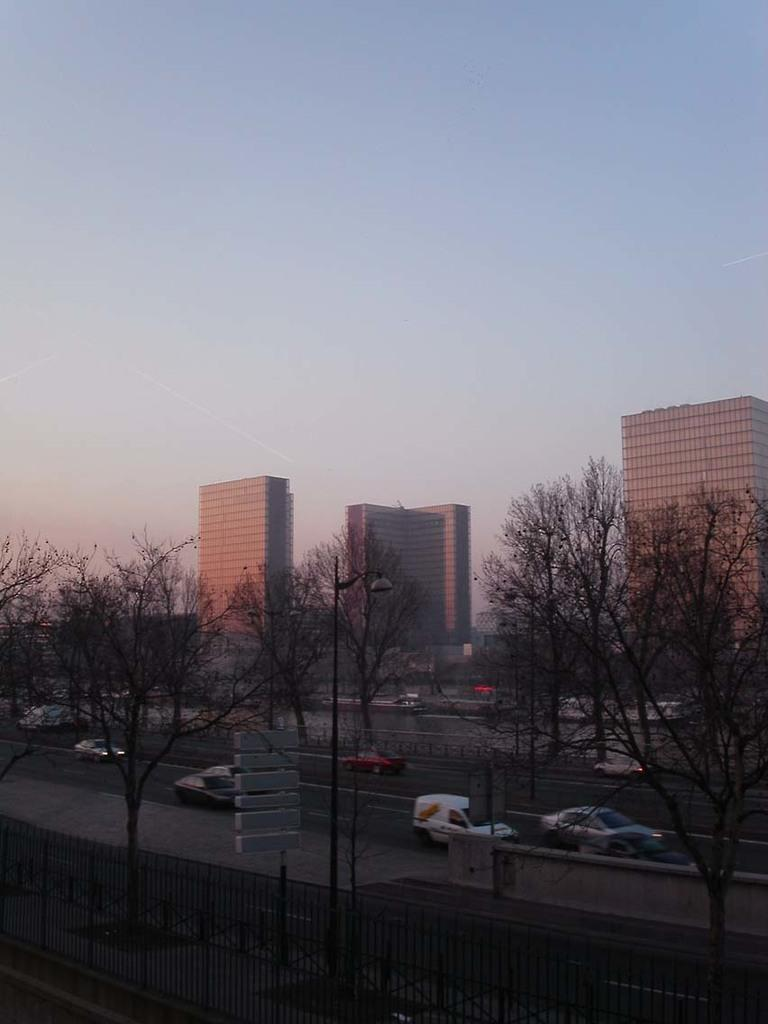What type of structures can be seen in the image? There are buildings in the image. What other natural elements are present in the image? There are trees in the image. What mode of transportation can be seen in the image? There are moving vehicles on the road in the image. What safety feature is visible in the image? There is railing in the image. What type of information might be conveyed by the sign boards in the image? The sign boards in the image might convey information about directions, warnings, or advertisements. What is visible in the background of the image? The sky is visible in the background of the image. What type of bell can be heard ringing in the image? There is no bell present in the image, and therefore no sound can be heard. What type of feather is visible on the trees in the image? There are no feathers visible on the trees in the image; only the trees themselves are present. 